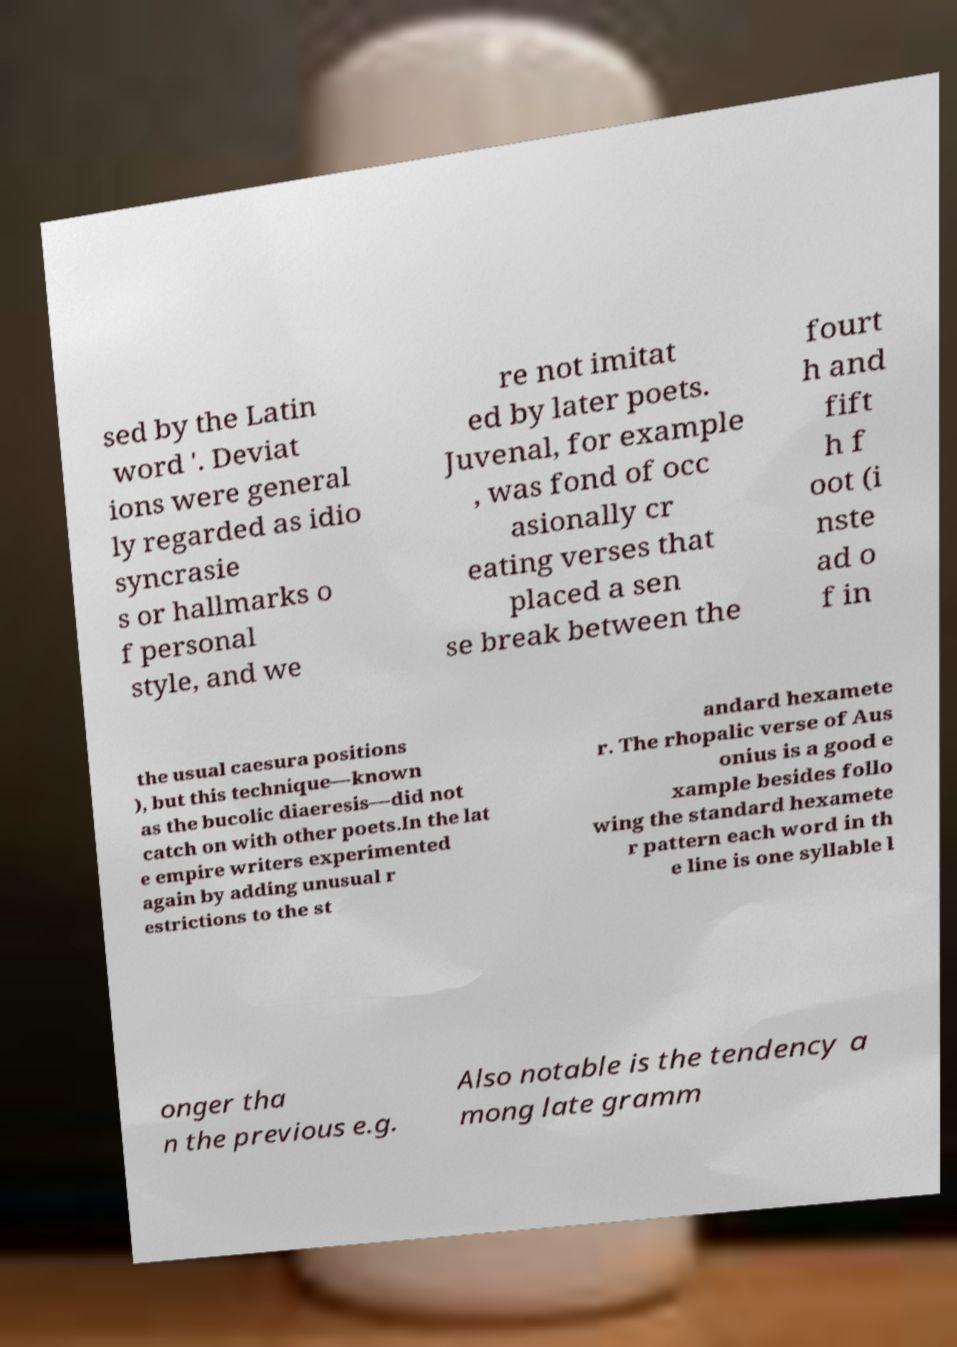What messages or text are displayed in this image? I need them in a readable, typed format. sed by the Latin word '. Deviat ions were general ly regarded as idio syncrasie s or hallmarks o f personal style, and we re not imitat ed by later poets. Juvenal, for example , was fond of occ asionally cr eating verses that placed a sen se break between the fourt h and fift h f oot (i nste ad o f in the usual caesura positions ), but this technique—known as the bucolic diaeresis—did not catch on with other poets.In the lat e empire writers experimented again by adding unusual r estrictions to the st andard hexamete r. The rhopalic verse of Aus onius is a good e xample besides follo wing the standard hexamete r pattern each word in th e line is one syllable l onger tha n the previous e.g. Also notable is the tendency a mong late gramm 